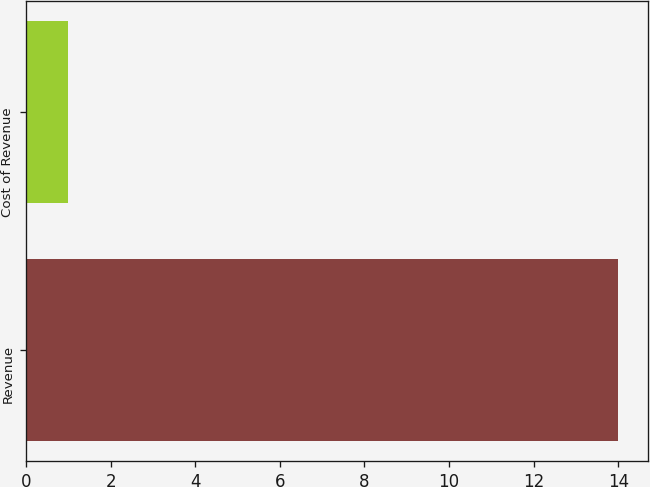Convert chart to OTSL. <chart><loc_0><loc_0><loc_500><loc_500><bar_chart><fcel>Revenue<fcel>Cost of Revenue<nl><fcel>14<fcel>1<nl></chart> 